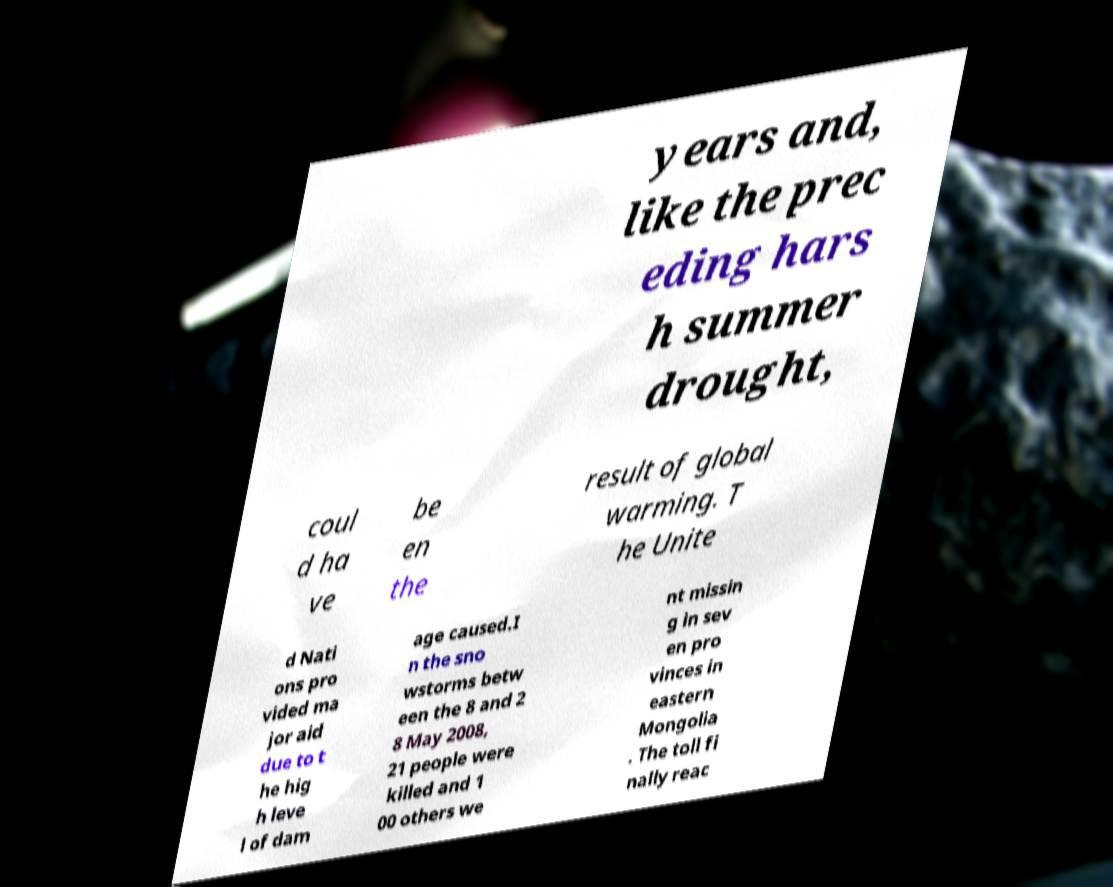What messages or text are displayed in this image? I need them in a readable, typed format. years and, like the prec eding hars h summer drought, coul d ha ve be en the result of global warming. T he Unite d Nati ons pro vided ma jor aid due to t he hig h leve l of dam age caused.I n the sno wstorms betw een the 8 and 2 8 May 2008, 21 people were killed and 1 00 others we nt missin g in sev en pro vinces in eastern Mongolia . The toll fi nally reac 